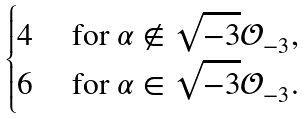<formula> <loc_0><loc_0><loc_500><loc_500>\begin{cases} 4 & \text { for $\alpha \not \in \sqrt{-3} \mathcal{O}_{-3}$, } \\ 6 & \text { for $\alpha \in \sqrt{-3} \mathcal{O}_{-3}$. } \end{cases}</formula> 